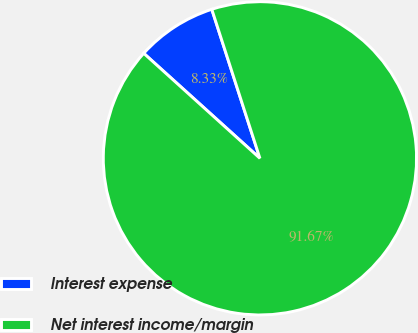Convert chart. <chart><loc_0><loc_0><loc_500><loc_500><pie_chart><fcel>Interest expense<fcel>Net interest income/margin<nl><fcel>8.33%<fcel>91.67%<nl></chart> 